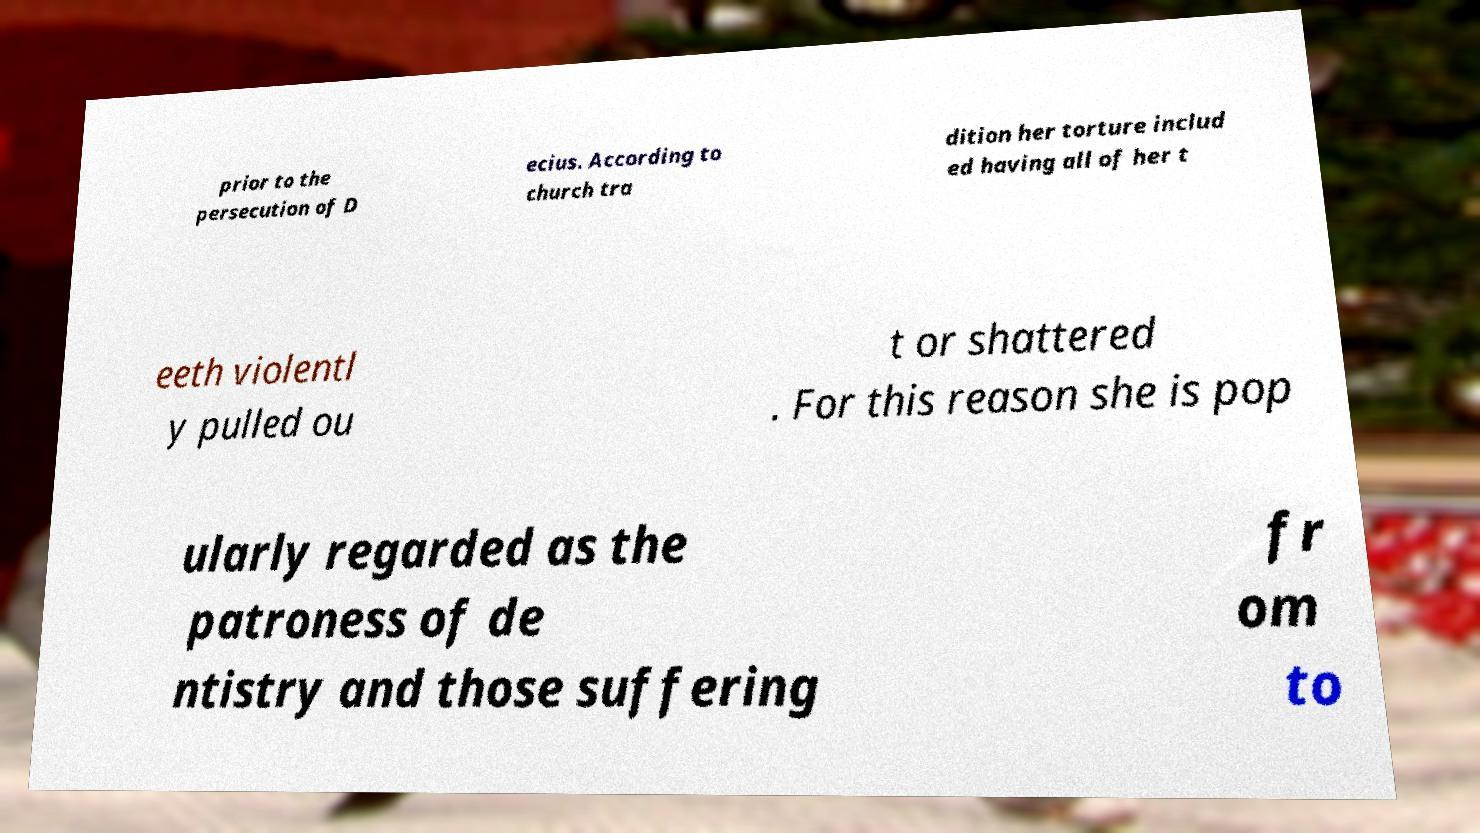Can you accurately transcribe the text from the provided image for me? prior to the persecution of D ecius. According to church tra dition her torture includ ed having all of her t eeth violentl y pulled ou t or shattered . For this reason she is pop ularly regarded as the patroness of de ntistry and those suffering fr om to 